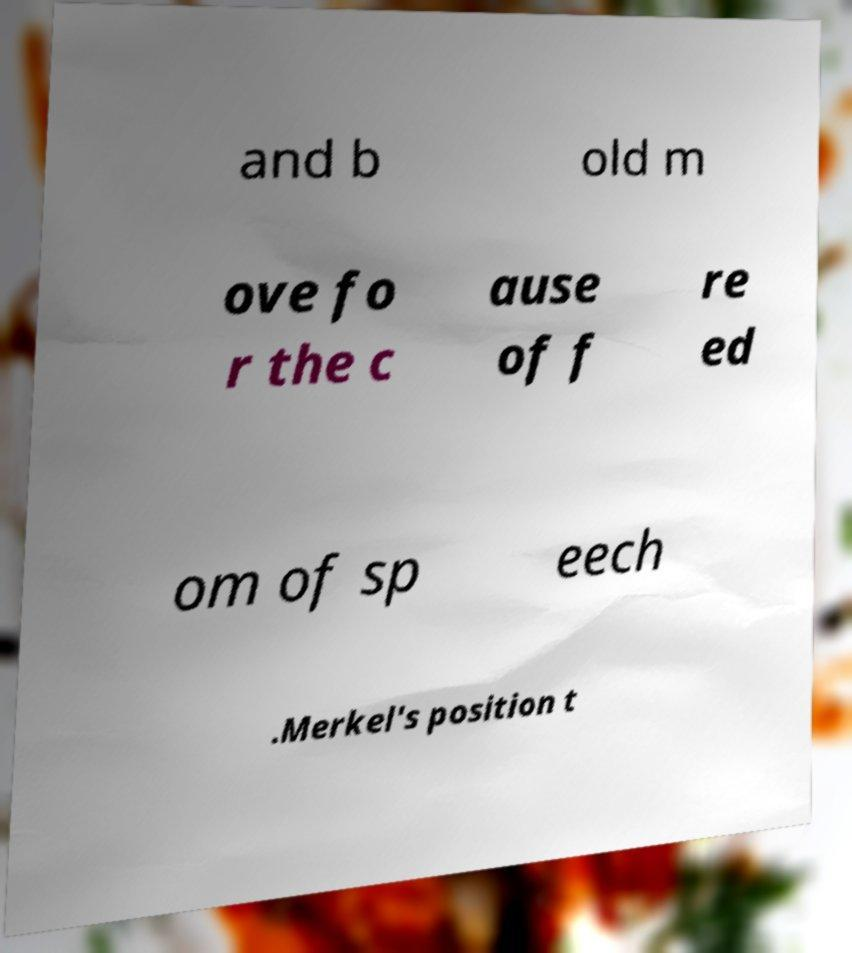Could you hypothesize a possible event where this text would be significant? Hypothesizing from the fragment mentioning freedom of speech and a political figure, the text could be part of a speech, a protest sign, or a statement from a political event or rally where such themes were important. It might represent a call to action or a defense of certain freedoms within a political context. 